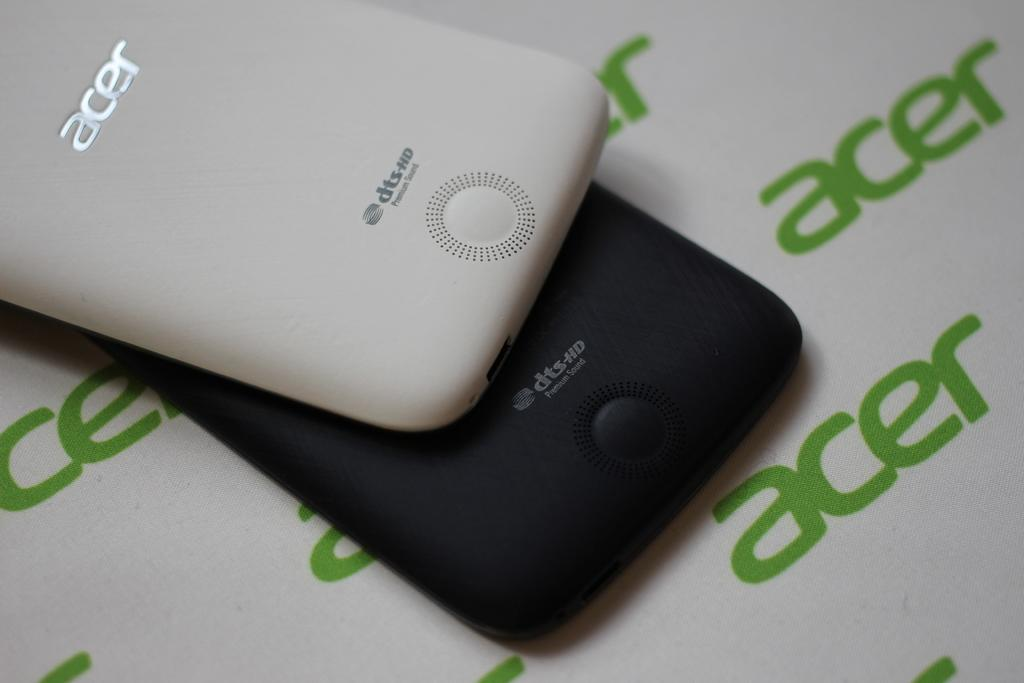Provide a one-sentence caption for the provided image. a black and a white cell phone on an acer print background. 